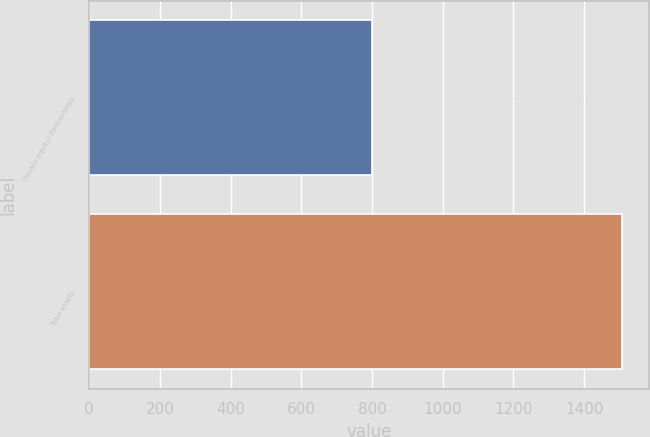<chart> <loc_0><loc_0><loc_500><loc_500><bar_chart><fcel>Private equity/ Partnerships<fcel>Total assets<nl><fcel>799<fcel>1507<nl></chart> 